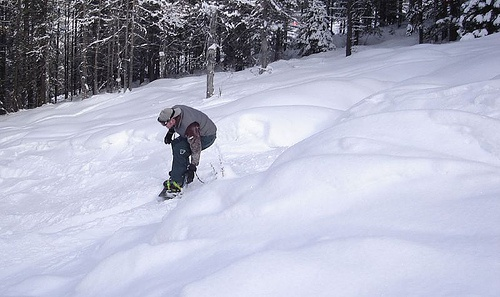Describe the objects in this image and their specific colors. I can see people in gray, black, and lavender tones and snowboard in gray, darkgray, and black tones in this image. 